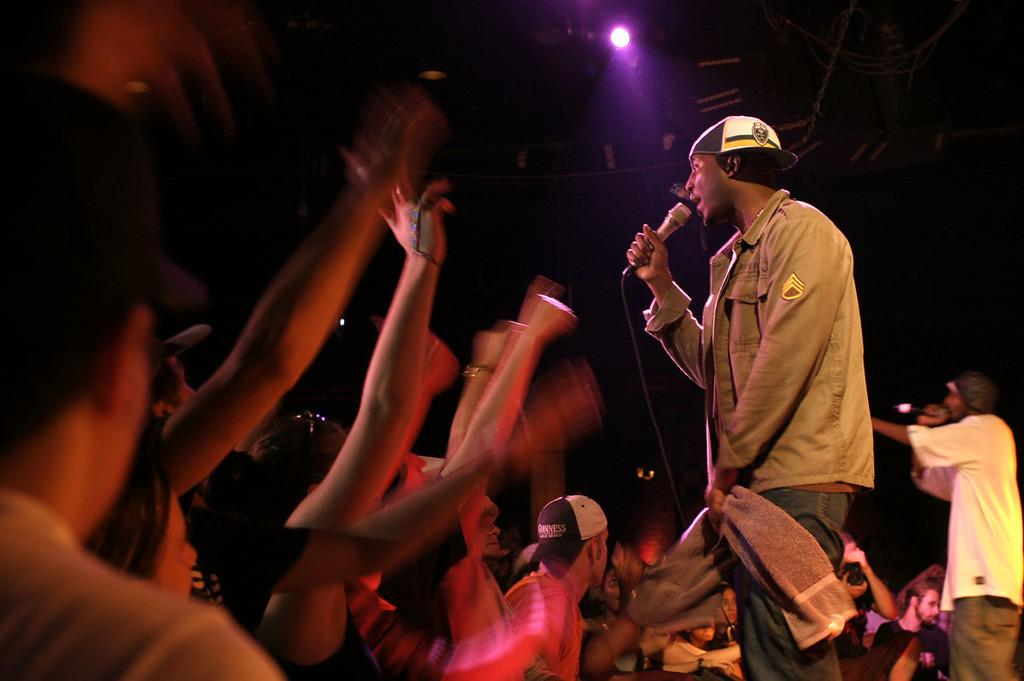What is happening on the left side of the image? There is a crowd on the left side of the image, and they are raising their hands. How would you describe the appearance of the crowd? The image of the crowd is blurry. What are the two persons on the right side of the image doing? The two persons are singing a song. What type of shame can be seen on the faces of the frogs in the image? There are no frogs present in the image, so it is not possible to determine if they are experiencing any shame. What advice might the coach give to the two persons singing a song in the image? There is no coach present in the image, so it is not possible to determine what advice they might give. 